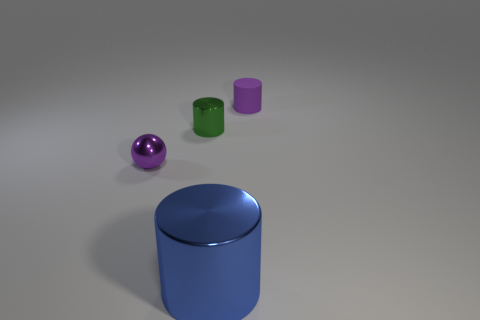Is the blue object made of the same material as the small purple object left of the rubber cylinder?
Provide a short and direct response. Yes. There is a purple object that is on the right side of the tiny purple ball; what is it made of?
Offer a terse response. Rubber. Are there the same number of purple things that are behind the green cylinder and large blue cylinders?
Make the answer very short. Yes. Are there any other things that are the same size as the blue metallic cylinder?
Offer a terse response. No. What material is the tiny cylinder to the right of the big blue cylinder that is left of the tiny purple matte object?
Your answer should be very brief. Rubber. There is a shiny object that is in front of the green object and behind the blue shiny object; what shape is it?
Keep it short and to the point. Sphere. There is a rubber thing that is the same shape as the large metal object; what is its size?
Keep it short and to the point. Small. Is the number of green metal things that are on the left side of the ball less than the number of purple cylinders?
Offer a terse response. Yes. There is a object behind the small green metallic cylinder; how big is it?
Provide a succinct answer. Small. There is another metallic thing that is the same shape as the blue object; what color is it?
Your answer should be very brief. Green. 